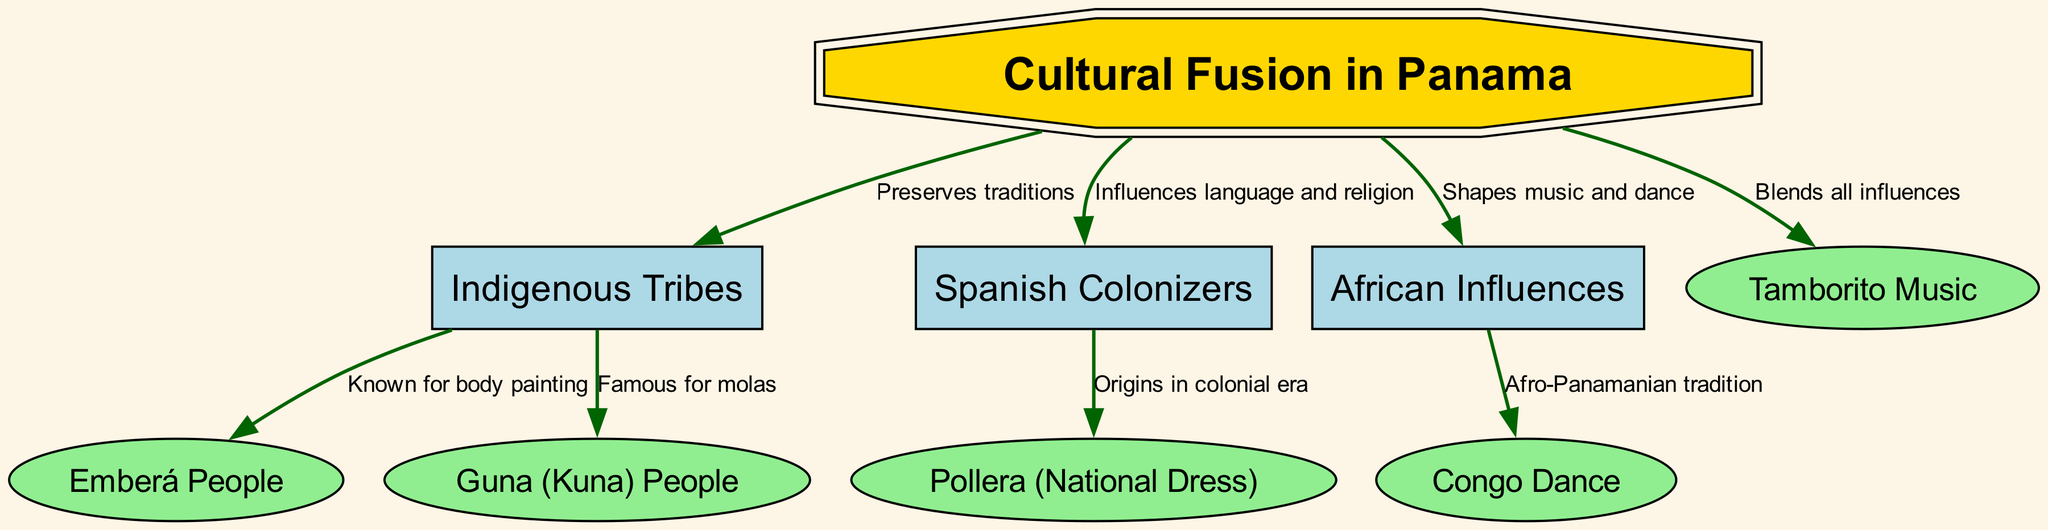What is the main theme of the diagram? The diagram centers around the concept of "Cultural Fusion in Panama," which is prominently labeled at the top as the overarching topic. This label connects to the various cultural influences depicted in the diagram.
Answer: Cultural Fusion in Panama How many indigenous tribes are represented in the diagram? There are two specific indigenous tribes mentioned in the diagram: the Emberá and the Guna (Kuna) People, each connected to the "Indigenous Tribes" node.
Answer: 2 What kind of dance is associated with African influences in Panama? The diagram shows that the Congo Dance is related to African influences, indicating that this type of dance is part of the cultural heritage shaped by African immigrants.
Answer: Congo Dance Which element in the diagram is noted for its origins in the colonial era? The Pollera, which is the national dress of Panama, is highlighted in the diagram as having origins in the colonial era, illustrating its historical significance.
Answer: Pollera What does cultural fusion in Panama blend according to the diagram? The diagram specifies that the "Tamborito Music" blends all influences, capturing the essence of the fusion of indigenous, Spanish, and African cultures.
Answer: Blends all influences How does Spanish colonization influence Panama's culture? Spanish colonization primarily influences language and religion in Panama, as indicated by the arrow connecting the Spanish node with the cultural fusion node.
Answer: Influences language and religion Which indigenous tribe is known for body painting? The diagram identifies the Emberá People as being known for body painting, showcasing a specific cultural practice associated with this tribe.
Answer: Emberá People What is a unique feature of the Guna (Kuna) People as depicted in the diagram? The Guna (Kuna) People are famous for molas, a traditional textile art form, linking their cultural identity to this unique craft in the diagram.
Answer: Famous for molas 